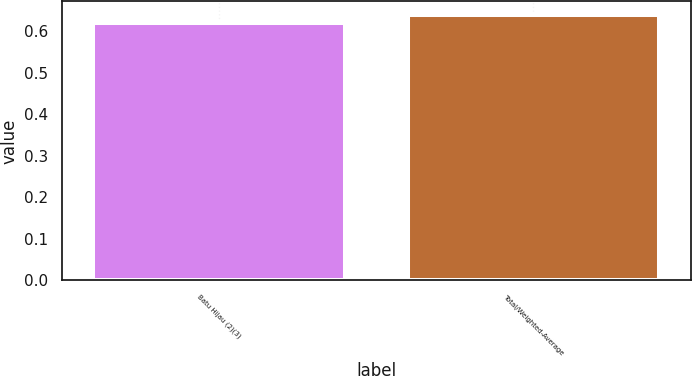<chart> <loc_0><loc_0><loc_500><loc_500><bar_chart><fcel>Batu Hijau (2)(3)<fcel>Total/Weighted-Average<nl><fcel>0.62<fcel>0.64<nl></chart> 